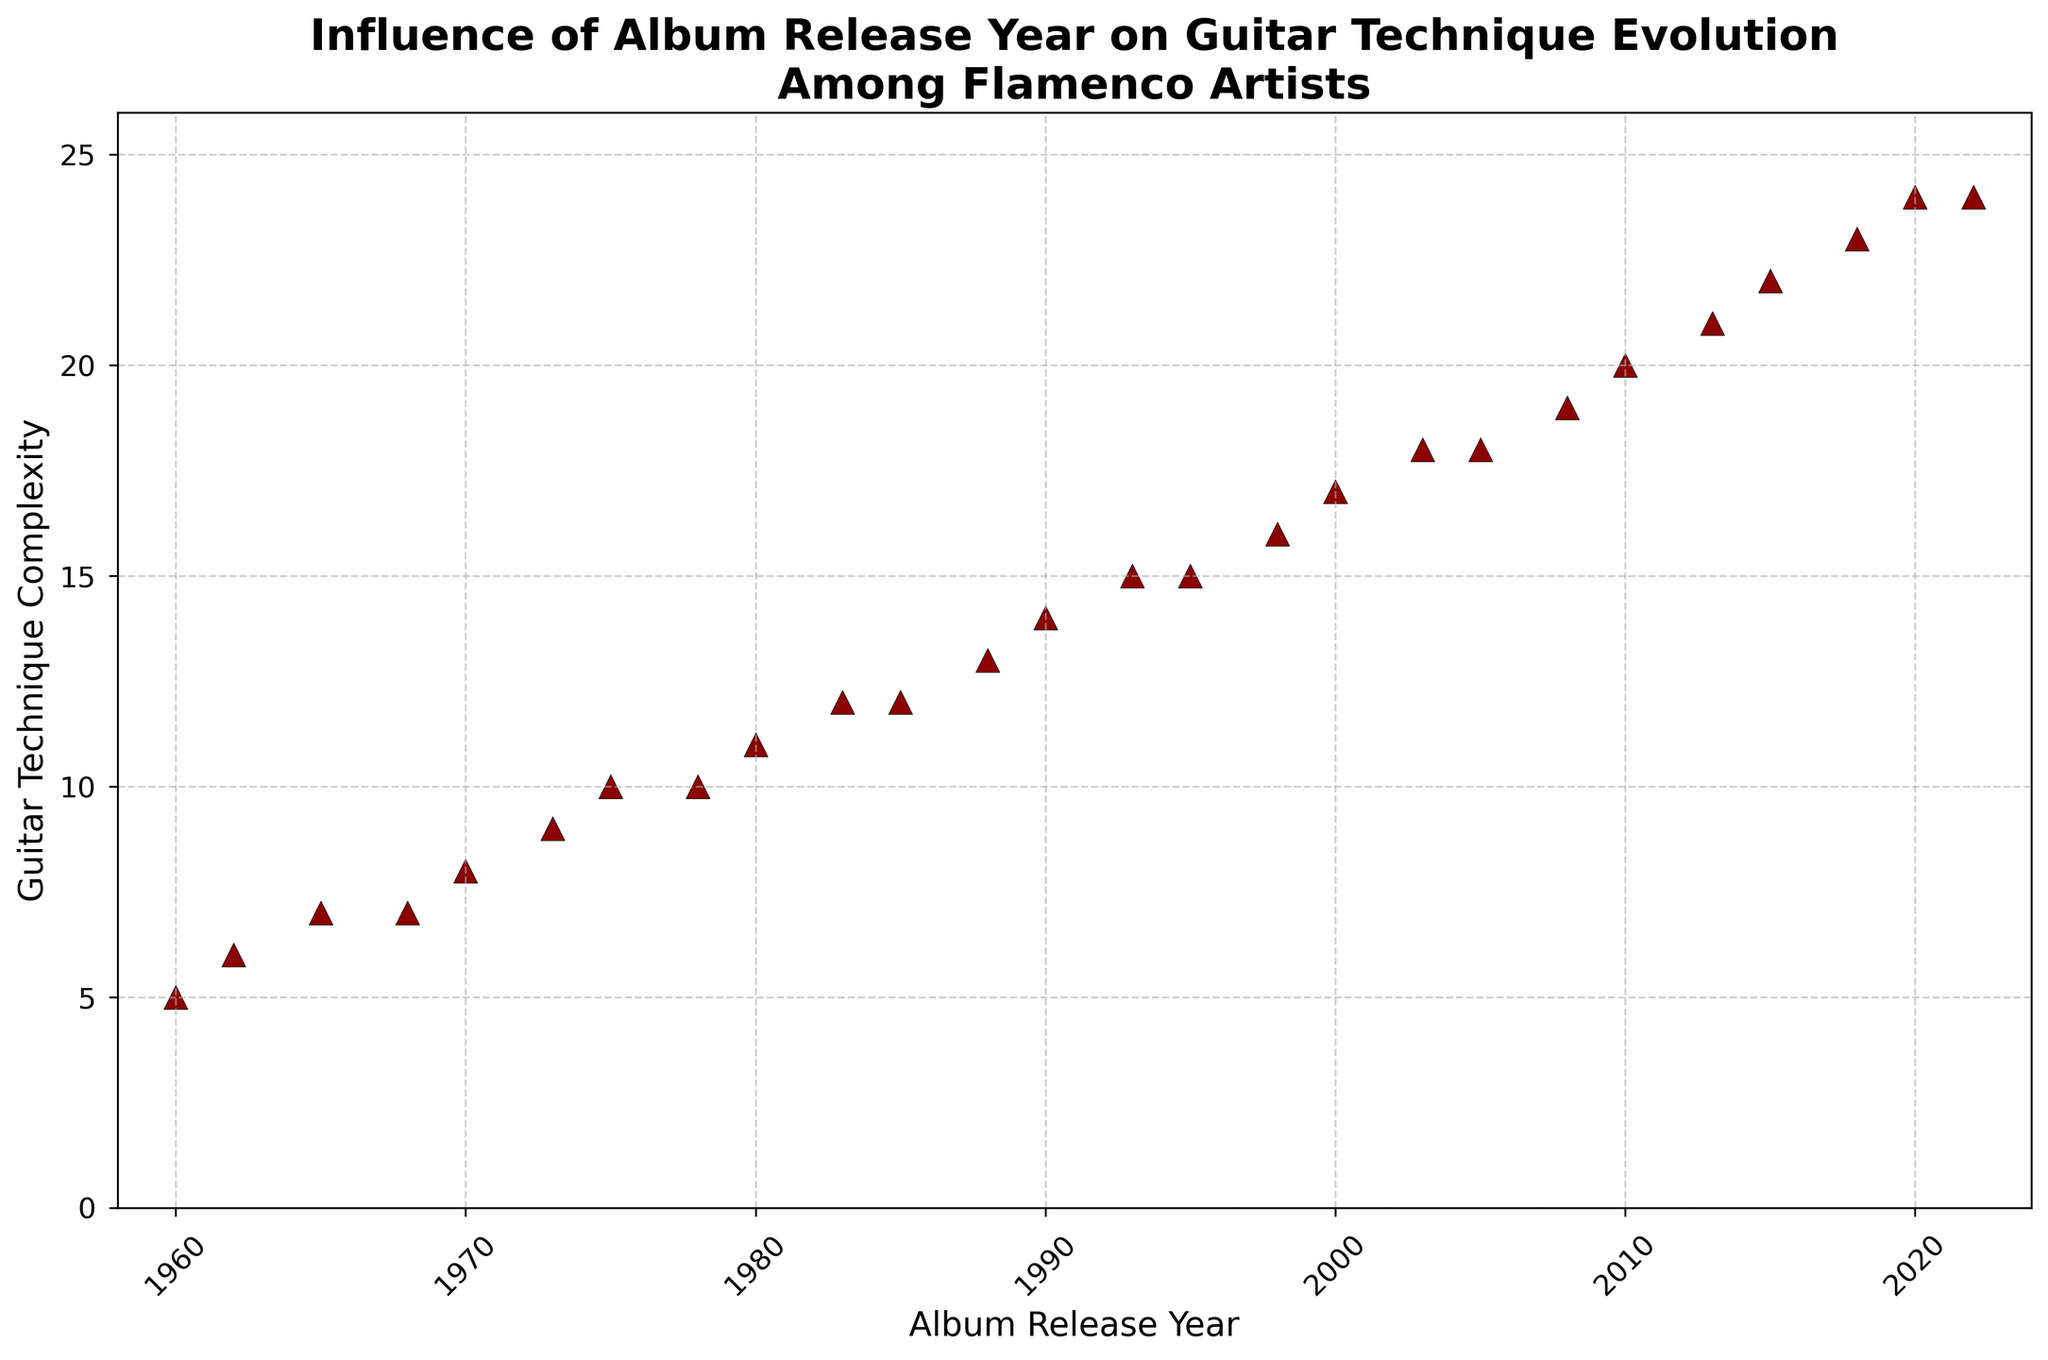What is the overall trend between the Album Release Year and Guitar Technique Complexity? The scatter plot shows an upward trend in Guitar Technique Complexity as the Album Release Year progresses, indicating that guitar techniques have become more complex over time.
Answer: Increasing trend What was the Guitar Technique Complexity in the year 1980? To find this, look at the data point at 1980 and read the Guitar Technique Complexity value from the y-axis.
Answer: 11 Between which years did the Guitar Technique Complexity remain the same at the highest level? The scatter plot shows that the highest Guitar Technique Complexity is 24, which occurs in both 2020 and 2022. Therefore, the complexity remained the same between these two years.
Answer: 2020 and 2022 How many years show a Guitar Technique Complexity of 18? Find the number of data points that align with 18 on the y-axis. There are two such points corresponding to the years 2003 and 2005.
Answer: 2 In which year did the Guitar Technique Complexity first reach 20? Locate the first data point on the y-axis that marks 20. This corresponds to the year 2010.
Answer: 2010 How does the Guitar Technique Complexity in 1968 compare to that in 2010? The Guitar Technique Complexity was 7 in 1968 and 20 in 2010. Thus, the complexity in 2010 was significantly higher.
Answer: 2010 is higher Is there any year where the Guitar Technique Complexity decreased compared to a previous year? Scrutinize the points along the scatter plot; however, the complexity consistently increases or remains constant over the years without any decrease.
Answer: No What is the difference in Guitar Technique Complexity between 2000 and 2020? The Guitar Technique Complexity in 2000 is 17, and in 2020 it is 24. The difference is 24 - 17 = 7.
Answer: 7 What is the average Guitar Technique Complexity from 1988 to 1998? The complexities for the years 1988, 1990, 1993, 1995, and 1998 are 13, 14, 15, 15, and 16 respectively. Add these values and divide by the number of data points: (13 + 14 + 15 + 15 + 16) / 5 = 73 / 5 = 14.6
Answer: 14.6 Observe the slope of the trend between the years 2005 and 2013. What does this suggest about the evolution during this time? The slope of the increase in Guitar Technique Complexity from 18 in 2005 to 21 in 2013 suggests a moderate yet consistent increase in technique complexity over these 8 years.
Answer: Moderate consistent increase 